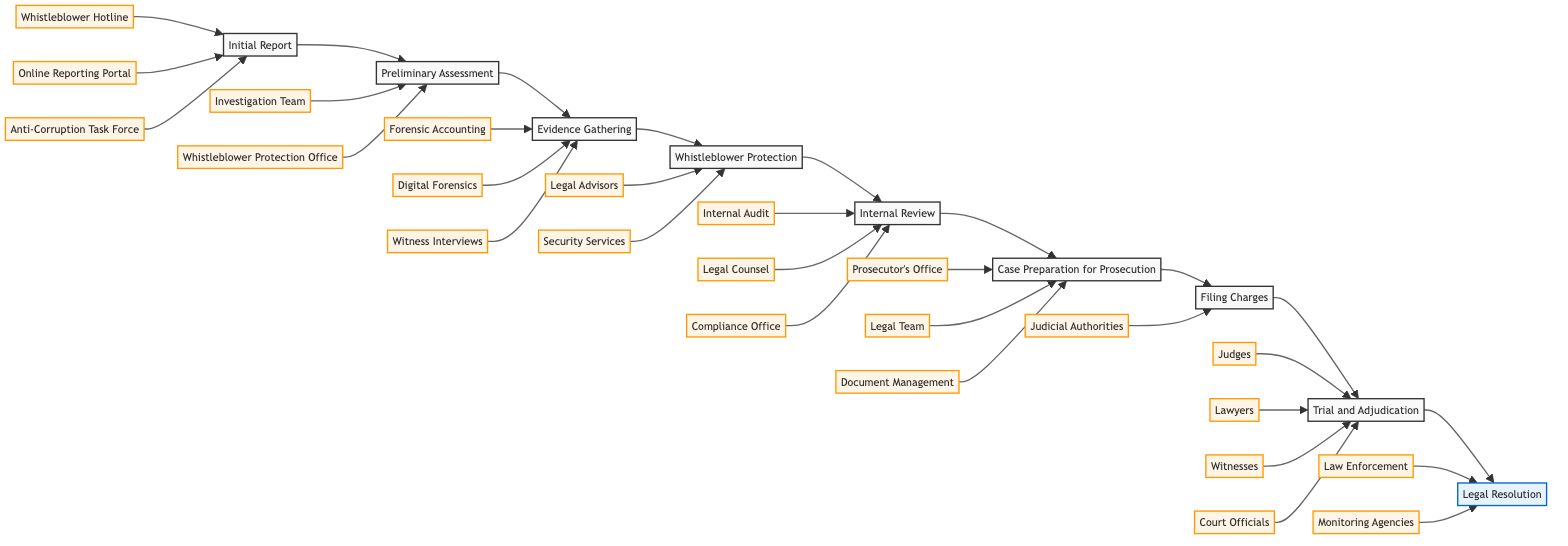What is the first step in the corruption case handling process? The first step is indicated as "Initial Report," which is the starting node of the flowchart.
Answer: Initial Report How many entities support the "Initial Report" step? Looking at the "Initial Report" step, there are three entities linked to it: Whistleblower Hotline, Online Reporting Portal, and Anti-Corruption Task Force.
Answer: 3 What step follows "Evidence Gathering"? The flowchart shows that "Whistleblower Protection" is the immediate step that comes after "Evidence Gathering."
Answer: Whistleblower Protection Which entity is associated with the "Filing Charges" step? The "Filing Charges" step is connected to the Prosecutor's Office and the Judicial Authorities, but the first entity that appears in this context is the Prosecutor's Office.
Answer: Prosecutor’s Office What is the last step in the corruption case handling process? The final node in the flowchart is "Legal Resolution," which signifies the conclusion of the case handling process.
Answer: Legal Resolution How many steps in total are represented in the flowchart? By counting each step from "Initial Report" to "Legal Resolution," there are a total of nine steps in the flowchart, including every node displayed.
Answer: 9 Which departments are involved in the "Case Preparation for Prosecution"? The entities connected to the "Case Preparation for Prosecution" step include the Prosecutor's Office, Legal Team, and Document Management Department.
Answer: Prosecutor’s Office, Legal Team, Document Management Department Before trial, which step ensures the safety of the whistleblower? The "Whistleblower Protection" step is explicitly focused on ensuring the safety and anonymity of the whistleblower before proceeding to trial.
Answer: Whistleblower Protection How does the "Internal Review" relate to the previous step? The "Internal Review" step follows directly after "Whistleblower Protection," demonstrating a sequential flow where the gathered evidence is internally reviewed and verified.
Answer: Its previous step is Whistleblower Protection 